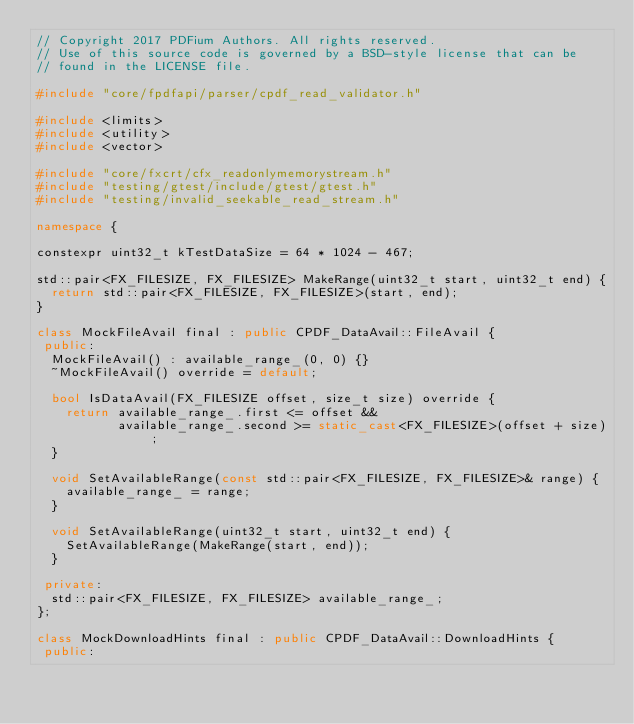Convert code to text. <code><loc_0><loc_0><loc_500><loc_500><_C++_>// Copyright 2017 PDFium Authors. All rights reserved.
// Use of this source code is governed by a BSD-style license that can be
// found in the LICENSE file.

#include "core/fpdfapi/parser/cpdf_read_validator.h"

#include <limits>
#include <utility>
#include <vector>

#include "core/fxcrt/cfx_readonlymemorystream.h"
#include "testing/gtest/include/gtest/gtest.h"
#include "testing/invalid_seekable_read_stream.h"

namespace {

constexpr uint32_t kTestDataSize = 64 * 1024 - 467;

std::pair<FX_FILESIZE, FX_FILESIZE> MakeRange(uint32_t start, uint32_t end) {
  return std::pair<FX_FILESIZE, FX_FILESIZE>(start, end);
}

class MockFileAvail final : public CPDF_DataAvail::FileAvail {
 public:
  MockFileAvail() : available_range_(0, 0) {}
  ~MockFileAvail() override = default;

  bool IsDataAvail(FX_FILESIZE offset, size_t size) override {
    return available_range_.first <= offset &&
           available_range_.second >= static_cast<FX_FILESIZE>(offset + size);
  }

  void SetAvailableRange(const std::pair<FX_FILESIZE, FX_FILESIZE>& range) {
    available_range_ = range;
  }

  void SetAvailableRange(uint32_t start, uint32_t end) {
    SetAvailableRange(MakeRange(start, end));
  }

 private:
  std::pair<FX_FILESIZE, FX_FILESIZE> available_range_;
};

class MockDownloadHints final : public CPDF_DataAvail::DownloadHints {
 public:</code> 